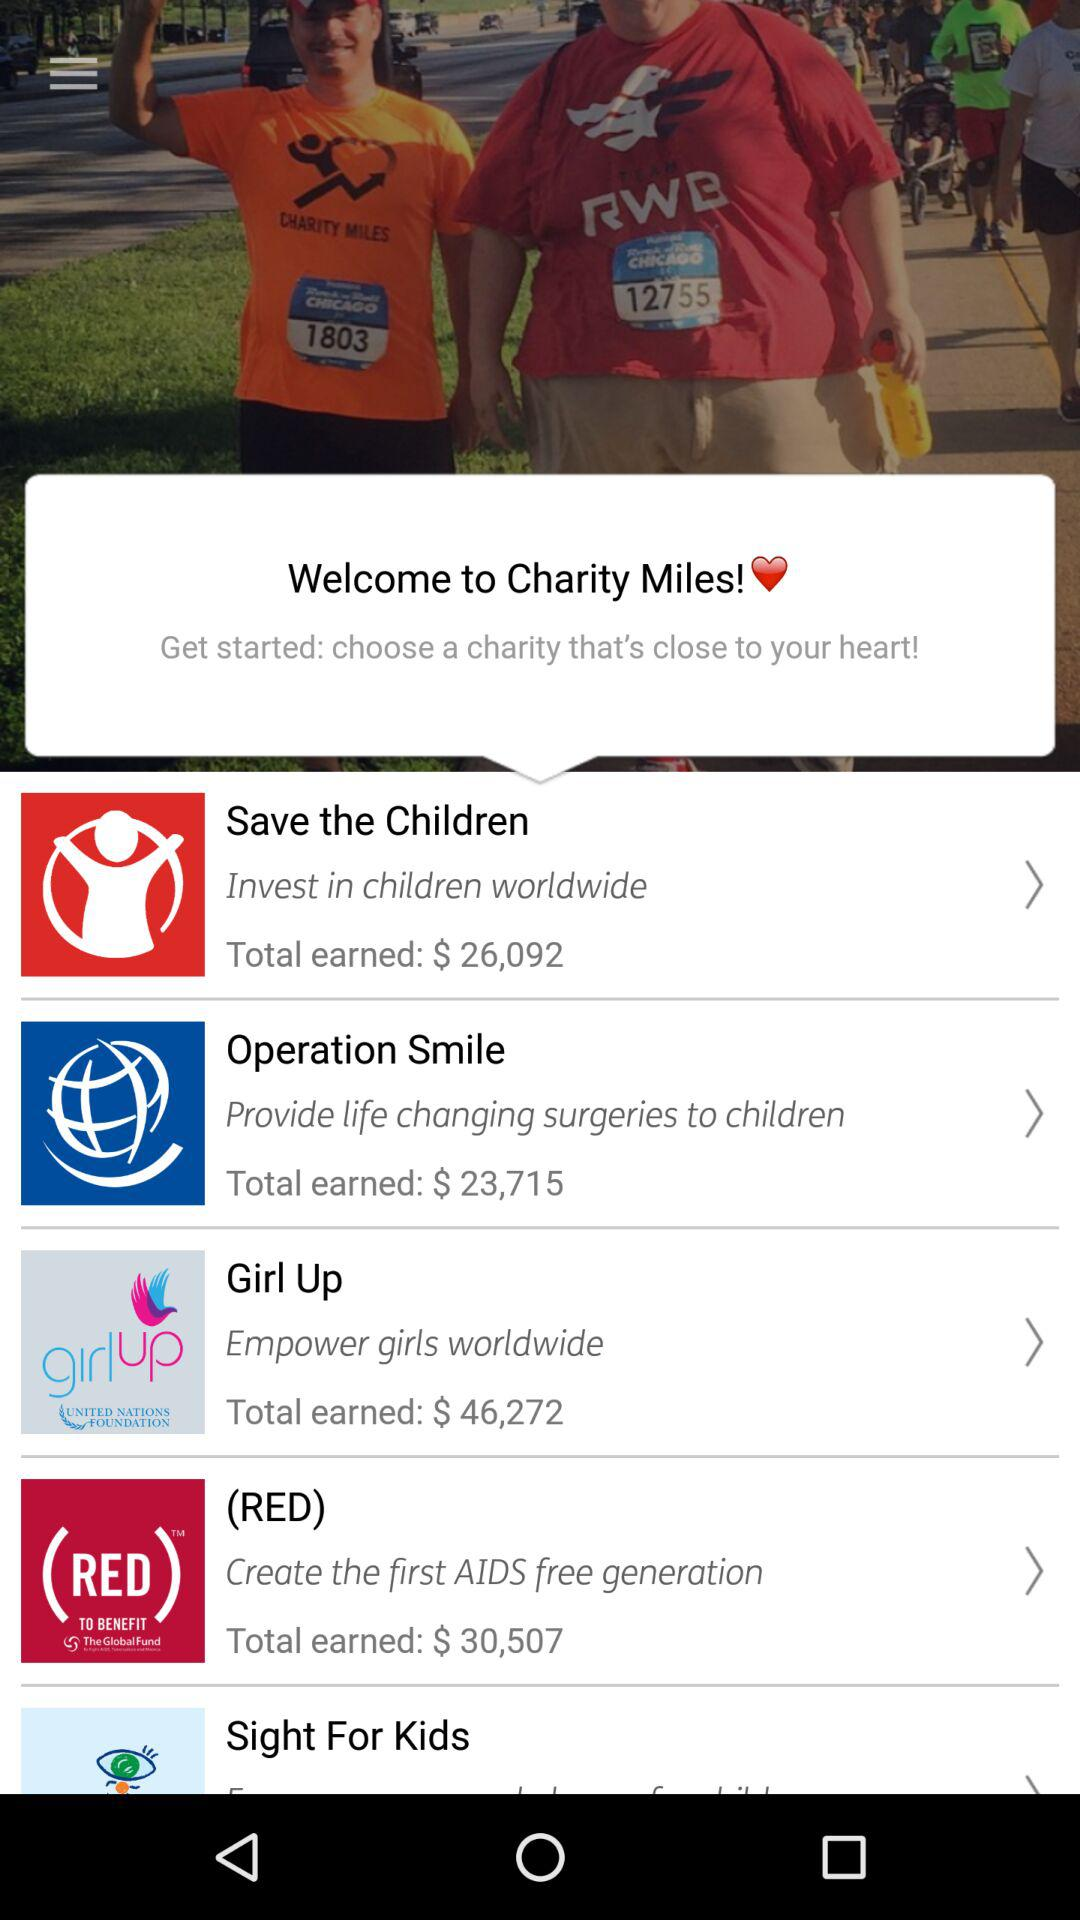Which organization aims to create the first AIDS-free generation? The organization that aims to create the first AIDS-free generation is "(RED)". 